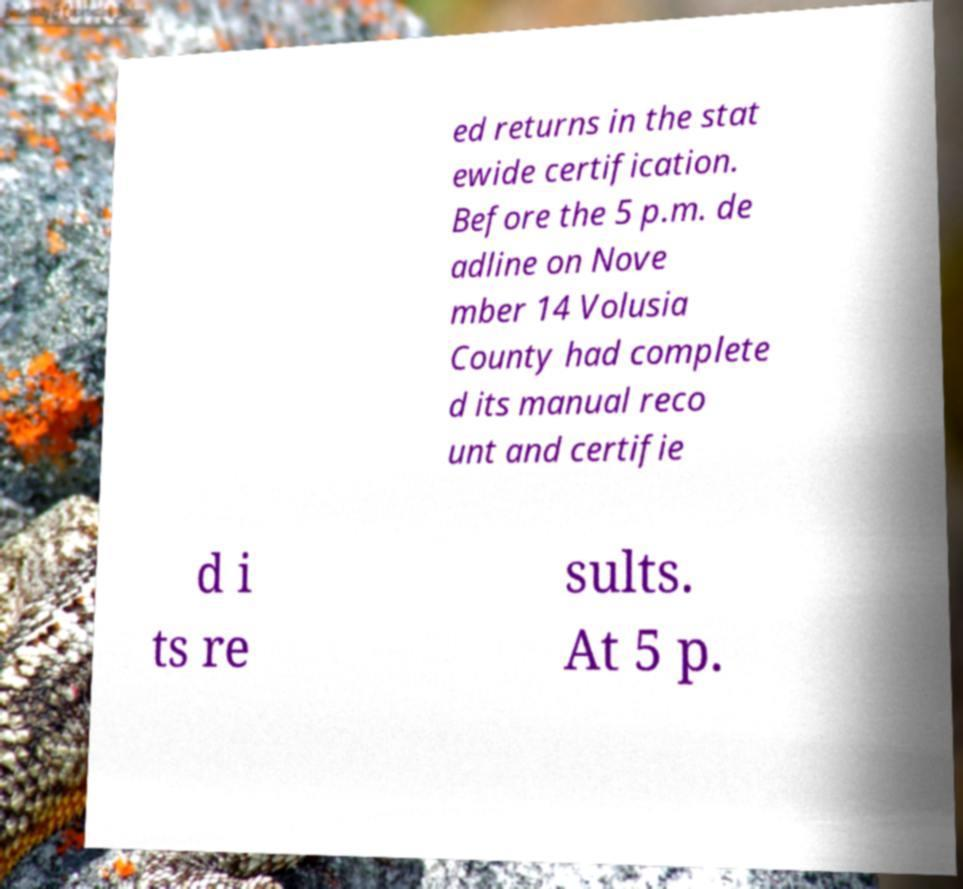Could you extract and type out the text from this image? ed returns in the stat ewide certification. Before the 5 p.m. de adline on Nove mber 14 Volusia County had complete d its manual reco unt and certifie d i ts re sults. At 5 p. 